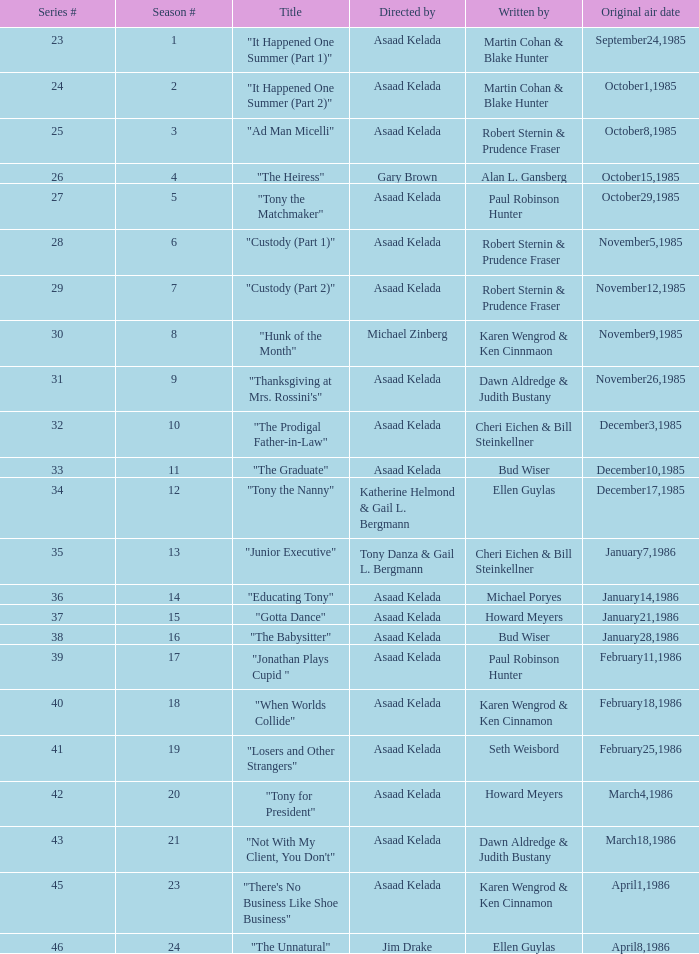Who were the authors of series episode #25? Robert Sternin & Prudence Fraser. 